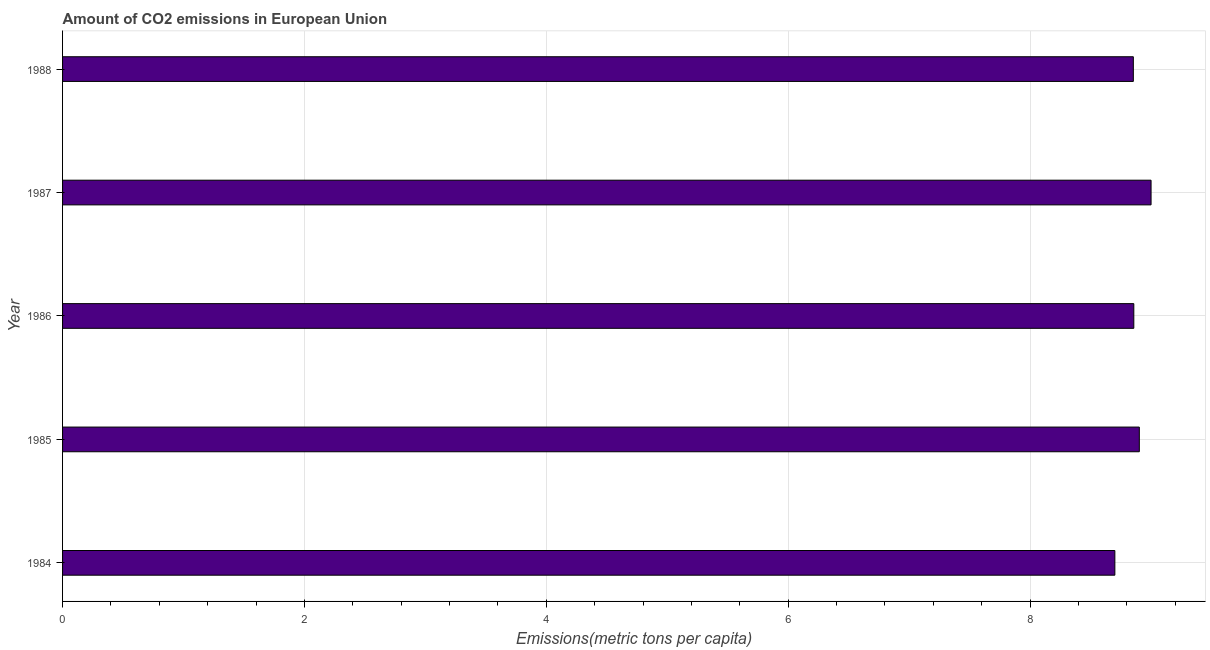Does the graph contain any zero values?
Offer a terse response. No. Does the graph contain grids?
Your answer should be very brief. Yes. What is the title of the graph?
Offer a very short reply. Amount of CO2 emissions in European Union. What is the label or title of the X-axis?
Keep it short and to the point. Emissions(metric tons per capita). What is the amount of co2 emissions in 1985?
Offer a terse response. 8.9. Across all years, what is the maximum amount of co2 emissions?
Offer a very short reply. 9. Across all years, what is the minimum amount of co2 emissions?
Your answer should be very brief. 8.7. In which year was the amount of co2 emissions minimum?
Provide a succinct answer. 1984. What is the sum of the amount of co2 emissions?
Provide a short and direct response. 44.32. What is the difference between the amount of co2 emissions in 1985 and 1987?
Your answer should be compact. -0.1. What is the average amount of co2 emissions per year?
Provide a succinct answer. 8.86. What is the median amount of co2 emissions?
Ensure brevity in your answer.  8.86. In how many years, is the amount of co2 emissions greater than 4.8 metric tons per capita?
Keep it short and to the point. 5. Do a majority of the years between 1987 and 1988 (inclusive) have amount of co2 emissions greater than 4 metric tons per capita?
Your answer should be very brief. Yes. What is the ratio of the amount of co2 emissions in 1984 to that in 1987?
Make the answer very short. 0.97. Is the amount of co2 emissions in 1987 less than that in 1988?
Provide a short and direct response. No. What is the difference between the highest and the second highest amount of co2 emissions?
Your response must be concise. 0.1. What is the difference between the highest and the lowest amount of co2 emissions?
Provide a short and direct response. 0.3. In how many years, is the amount of co2 emissions greater than the average amount of co2 emissions taken over all years?
Your response must be concise. 2. What is the difference between two consecutive major ticks on the X-axis?
Provide a succinct answer. 2. What is the Emissions(metric tons per capita) of 1984?
Your answer should be very brief. 8.7. What is the Emissions(metric tons per capita) in 1985?
Ensure brevity in your answer.  8.9. What is the Emissions(metric tons per capita) in 1986?
Provide a succinct answer. 8.86. What is the Emissions(metric tons per capita) in 1987?
Your answer should be very brief. 9. What is the Emissions(metric tons per capita) in 1988?
Provide a short and direct response. 8.85. What is the difference between the Emissions(metric tons per capita) in 1984 and 1985?
Keep it short and to the point. -0.2. What is the difference between the Emissions(metric tons per capita) in 1984 and 1986?
Provide a succinct answer. -0.16. What is the difference between the Emissions(metric tons per capita) in 1984 and 1987?
Provide a succinct answer. -0.3. What is the difference between the Emissions(metric tons per capita) in 1984 and 1988?
Keep it short and to the point. -0.15. What is the difference between the Emissions(metric tons per capita) in 1985 and 1986?
Give a very brief answer. 0.05. What is the difference between the Emissions(metric tons per capita) in 1985 and 1987?
Your response must be concise. -0.1. What is the difference between the Emissions(metric tons per capita) in 1985 and 1988?
Give a very brief answer. 0.05. What is the difference between the Emissions(metric tons per capita) in 1986 and 1987?
Provide a short and direct response. -0.14. What is the difference between the Emissions(metric tons per capita) in 1986 and 1988?
Offer a terse response. 0. What is the difference between the Emissions(metric tons per capita) in 1987 and 1988?
Keep it short and to the point. 0.15. What is the ratio of the Emissions(metric tons per capita) in 1984 to that in 1985?
Your answer should be very brief. 0.98. What is the ratio of the Emissions(metric tons per capita) in 1984 to that in 1988?
Provide a succinct answer. 0.98. What is the ratio of the Emissions(metric tons per capita) in 1985 to that in 1986?
Provide a succinct answer. 1. What is the ratio of the Emissions(metric tons per capita) in 1985 to that in 1987?
Your answer should be compact. 0.99. 